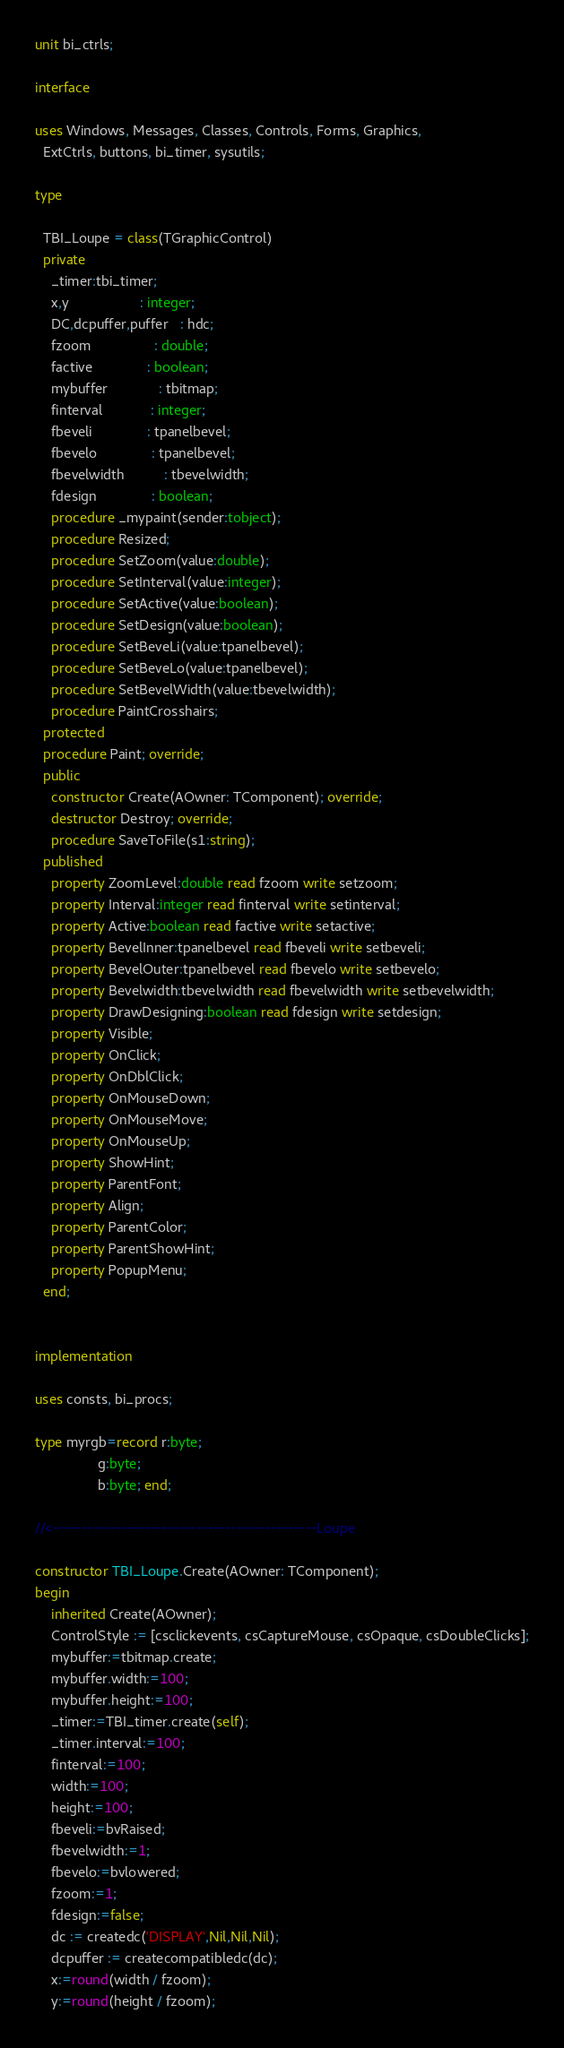Convert code to text. <code><loc_0><loc_0><loc_500><loc_500><_Pascal_>unit bi_ctrls;

interface

uses Windows, Messages, Classes, Controls, Forms, Graphics,
  ExtCtrls, buttons, bi_timer, sysutils;

type

  TBI_Loupe = class(TGraphicControl)
  private
    _timer:tbi_timer;
    x,y                  : integer;
    DC,dcpuffer,puffer   : hdc;
    fzoom                : double;
    factive              : boolean;
    mybuffer             : tbitmap;
    finterval            : integer;
    fbeveli              : tpanelbevel;
    fbevelo              : tpanelbevel;
    fbevelwidth          : tbevelwidth;
    fdesign              : boolean;
    procedure _mypaint(sender:tobject);
    procedure Resized;
    procedure SetZoom(value:double);
    procedure SetInterval(value:integer);
    procedure SetActive(value:boolean);
    procedure SetDesign(value:boolean);
    procedure SetBeveLi(value:tpanelbevel);
    procedure SetBeveLo(value:tpanelbevel);
    procedure SetBevelWidth(value:tbevelwidth);
    procedure PaintCrosshairs;
  protected
  procedure Paint; override;
  public
    constructor Create(AOwner: TComponent); override;
    destructor Destroy; override;
    procedure SaveToFile(s1:string);
  published
    property ZoomLevel:double read fzoom write setzoom;
    property Interval:integer read finterval write setinterval;
    property Active:boolean read factive write setactive;
    property BevelInner:tpanelbevel read fbeveli write setbeveli;
    property BevelOuter:tpanelbevel read fbevelo write setbevelo;
    property Bevelwidth:tbevelwidth read fbevelwidth write setbevelwidth;
    property DrawDesigning:boolean read fdesign write setdesign;
    property Visible;
    property OnClick;
    property OnDblClick;
    property OnMouseDown;
    property OnMouseMove;
    property OnMouseUp;
    property ShowHint;
    property ParentFont;
    property Align;
    property ParentColor;
    property ParentShowHint;
    property PopupMenu;
  end;


implementation

uses consts, bi_procs;

type myrgb=record r:byte;
                g:byte;
                b:byte; end;

//<----------------------------------------------Loupe

constructor TBI_Loupe.Create(AOwner: TComponent);
begin
    inherited Create(AOwner);
    ControlStyle := [csclickevents, csCaptureMouse, csOpaque, csDoubleClicks];
    mybuffer:=tbitmap.create;
    mybuffer.width:=100;
    mybuffer.height:=100;
    _timer:=TBI_timer.create(self);
    _timer.interval:=100;
    finterval:=100;
    width:=100;
    height:=100;
    fbeveli:=bvRaised;
    fbevelwidth:=1;
    fbevelo:=bvlowered;
    fzoom:=1;
    fdesign:=false;
    dc := createdc('DISPLAY',Nil,Nil,Nil);
    dcpuffer := createcompatibledc(dc);
    x:=round(width / fzoom);
    y:=round(height / fzoom);</code> 